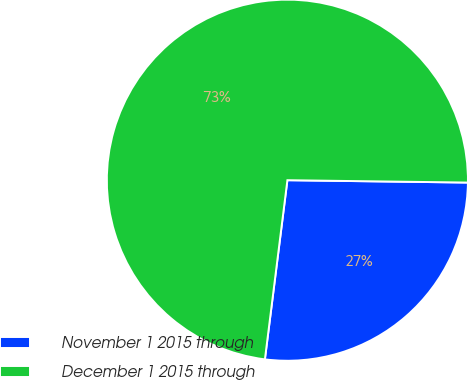<chart> <loc_0><loc_0><loc_500><loc_500><pie_chart><fcel>November 1 2015 through<fcel>December 1 2015 through<nl><fcel>26.78%<fcel>73.22%<nl></chart> 